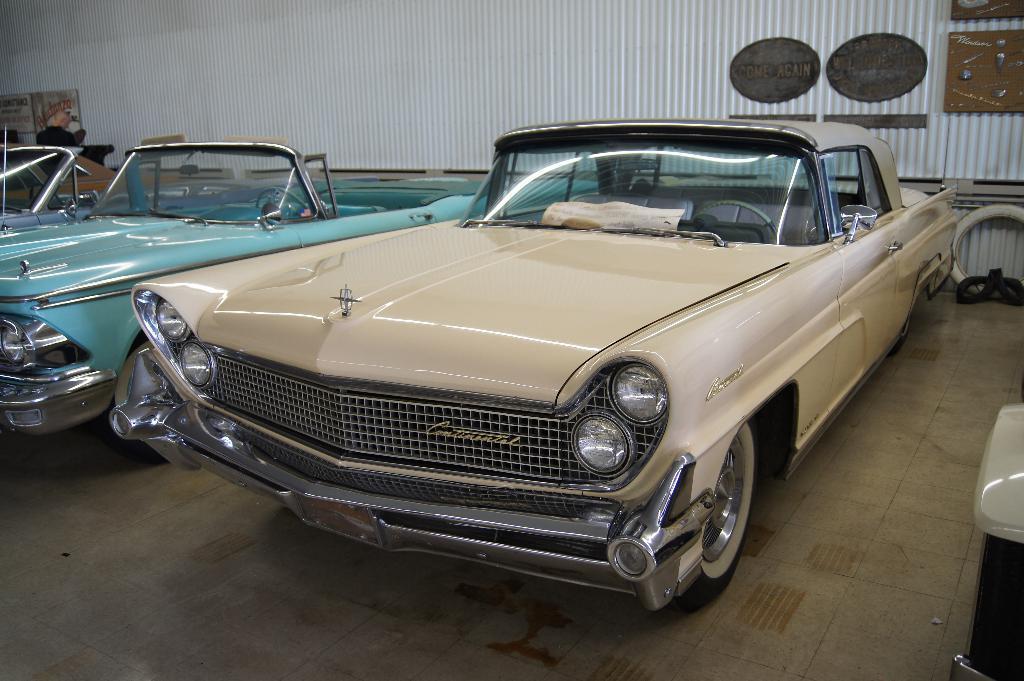In one or two sentences, can you explain what this image depicts? In this image, I can see three cars, which are parked. In the background, these are the boards, which are attached to the iron sheets. On the right side of the image, these look like the objects, which are placed on the floor. 